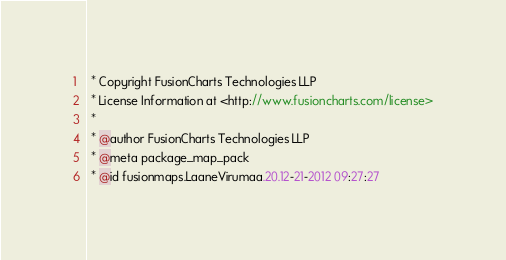Convert code to text. <code><loc_0><loc_0><loc_500><loc_500><_JavaScript_> * Copyright FusionCharts Technologies LLP
 * License Information at <http://www.fusioncharts.com/license>
 *
 * @author FusionCharts Technologies LLP
 * @meta package_map_pack
 * @id fusionmaps.LaaneVirumaa.20.12-21-2012 09:27:27</code> 